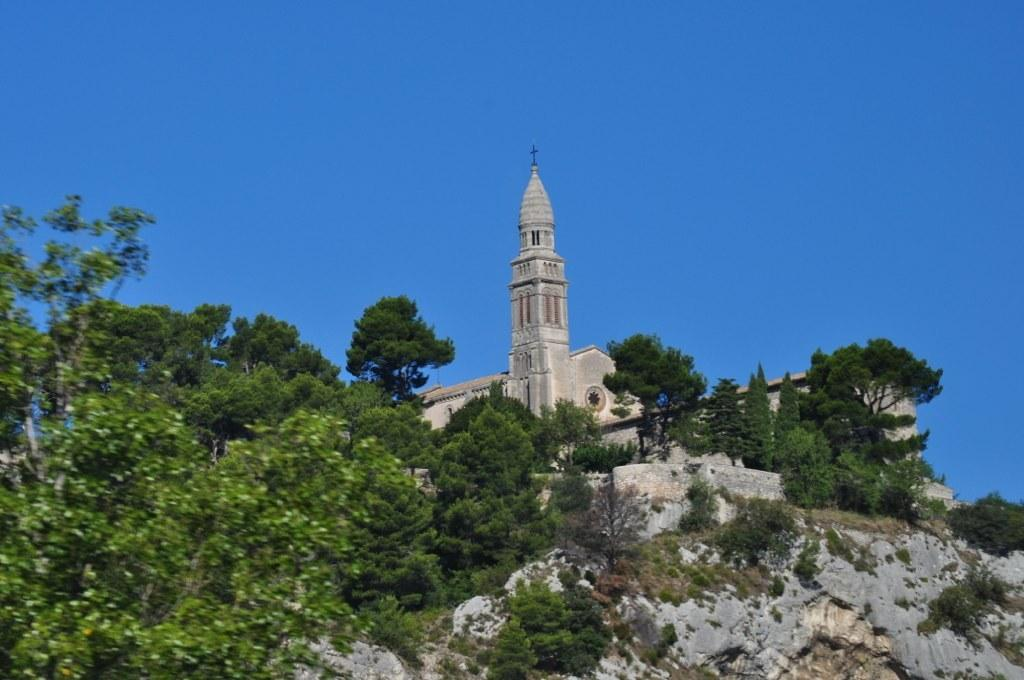What type of structure is present in the image? There is a building in the image. What natural elements can be seen in the image? There are trees and rocks in the image. What can be seen in the background of the image? The sky is visible in the background of the image. What type of mitten is being used by the secretary in the image? There is no secretary or mitten present in the image. 